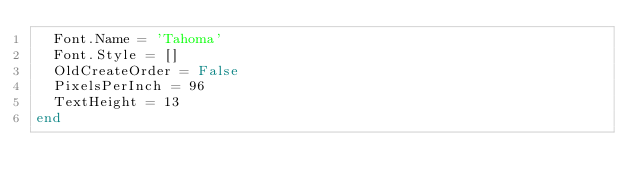<code> <loc_0><loc_0><loc_500><loc_500><_Pascal_>  Font.Name = 'Tahoma'
  Font.Style = []
  OldCreateOrder = False
  PixelsPerInch = 96
  TextHeight = 13
end
</code> 